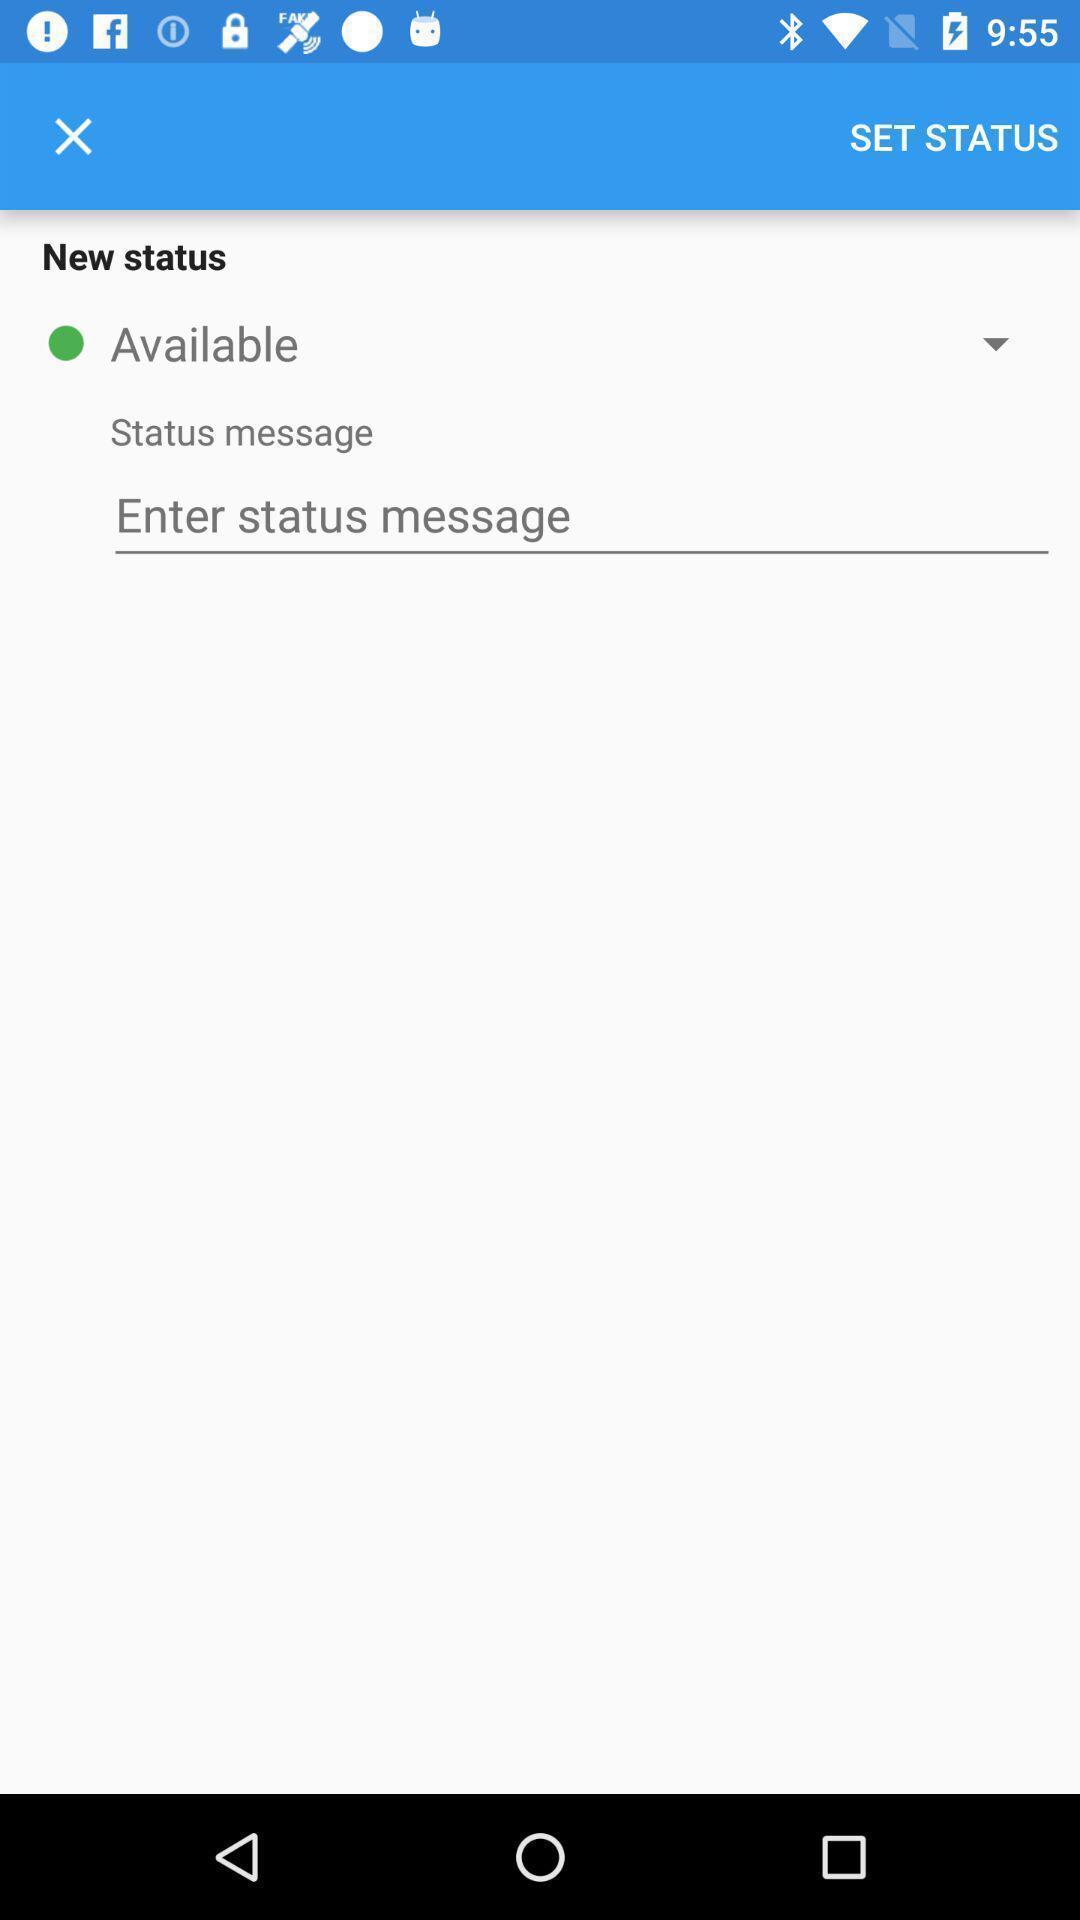Give me a narrative description of this picture. Status setting page. 